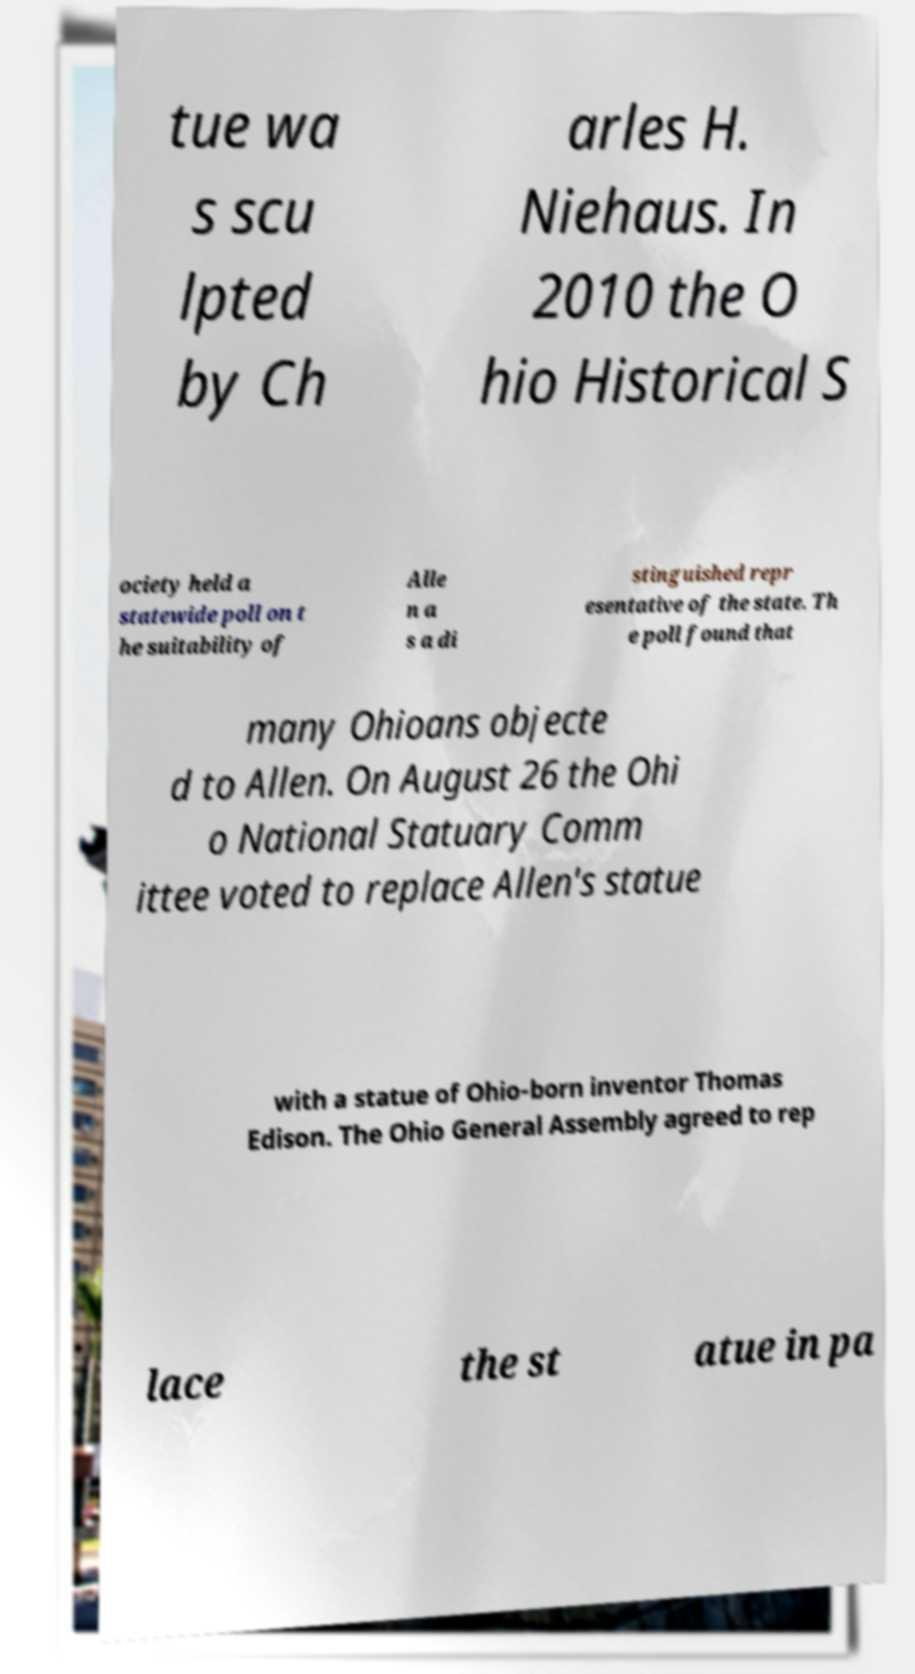What messages or text are displayed in this image? I need them in a readable, typed format. tue wa s scu lpted by Ch arles H. Niehaus. In 2010 the O hio Historical S ociety held a statewide poll on t he suitability of Alle n a s a di stinguished repr esentative of the state. Th e poll found that many Ohioans objecte d to Allen. On August 26 the Ohi o National Statuary Comm ittee voted to replace Allen's statue with a statue of Ohio-born inventor Thomas Edison. The Ohio General Assembly agreed to rep lace the st atue in pa 